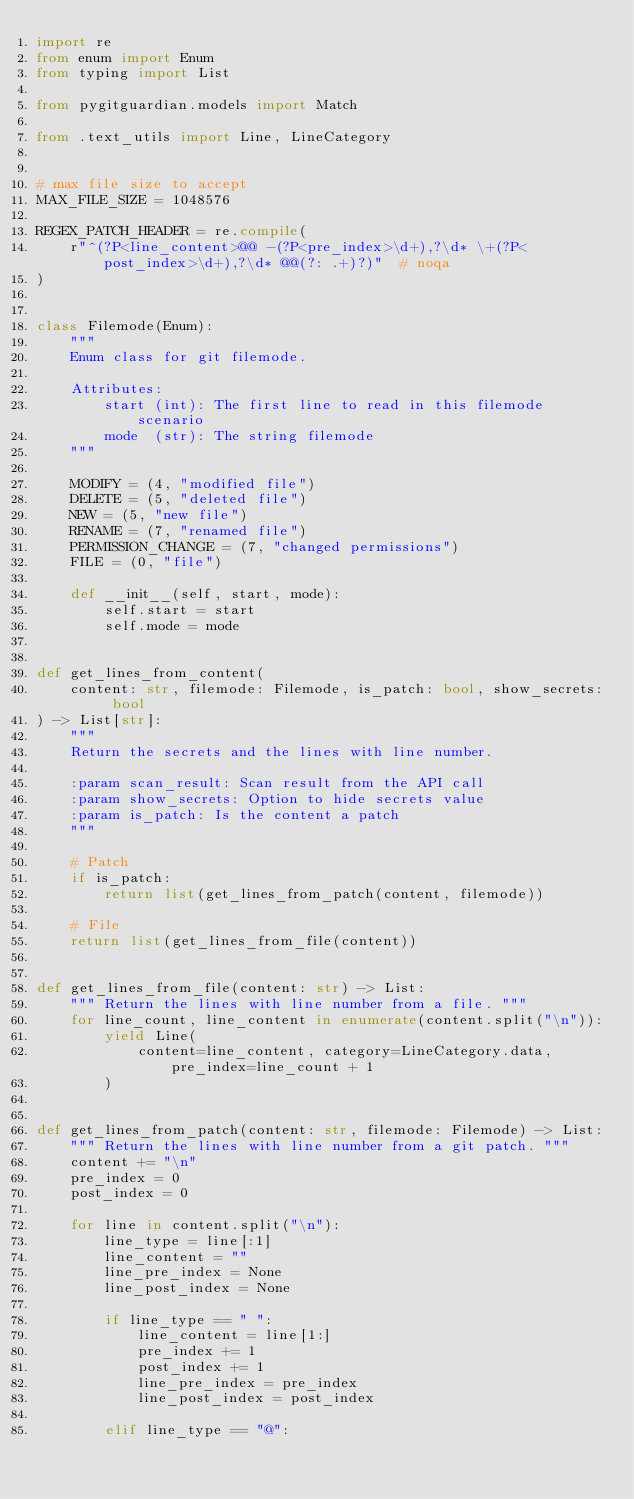Convert code to text. <code><loc_0><loc_0><loc_500><loc_500><_Python_>import re
from enum import Enum
from typing import List

from pygitguardian.models import Match

from .text_utils import Line, LineCategory


# max file size to accept
MAX_FILE_SIZE = 1048576

REGEX_PATCH_HEADER = re.compile(
    r"^(?P<line_content>@@ -(?P<pre_index>\d+),?\d* \+(?P<post_index>\d+),?\d* @@(?: .+)?)"  # noqa
)


class Filemode(Enum):
    """
    Enum class for git filemode.

    Attributes:
        start (int): The first line to read in this filemode scenario
        mode  (str): The string filemode
    """

    MODIFY = (4, "modified file")
    DELETE = (5, "deleted file")
    NEW = (5, "new file")
    RENAME = (7, "renamed file")
    PERMISSION_CHANGE = (7, "changed permissions")
    FILE = (0, "file")

    def __init__(self, start, mode):
        self.start = start
        self.mode = mode


def get_lines_from_content(
    content: str, filemode: Filemode, is_patch: bool, show_secrets: bool
) -> List[str]:
    """
    Return the secrets and the lines with line number.

    :param scan_result: Scan result from the API call
    :param show_secrets: Option to hide secrets value
    :param is_patch: Is the content a patch
    """

    # Patch
    if is_patch:
        return list(get_lines_from_patch(content, filemode))

    # File
    return list(get_lines_from_file(content))


def get_lines_from_file(content: str) -> List:
    """ Return the lines with line number from a file. """
    for line_count, line_content in enumerate(content.split("\n")):
        yield Line(
            content=line_content, category=LineCategory.data, pre_index=line_count + 1
        )


def get_lines_from_patch(content: str, filemode: Filemode) -> List:
    """ Return the lines with line number from a git patch. """
    content += "\n"
    pre_index = 0
    post_index = 0

    for line in content.split("\n"):
        line_type = line[:1]
        line_content = ""
        line_pre_index = None
        line_post_index = None

        if line_type == " ":
            line_content = line[1:]
            pre_index += 1
            post_index += 1
            line_pre_index = pre_index
            line_post_index = post_index

        elif line_type == "@":</code> 